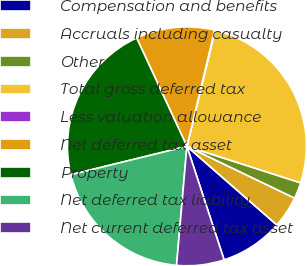Convert chart. <chart><loc_0><loc_0><loc_500><loc_500><pie_chart><fcel>Compensation and benefits<fcel>Accruals including casualty<fcel>Other<fcel>Total gross deferred tax<fcel>Less valuation allowance<fcel>Net deferred tax asset<fcel>Property<fcel>Net deferred tax liability<fcel>Net current deferred tax asset<nl><fcel>8.53%<fcel>4.3%<fcel>2.19%<fcel>26.14%<fcel>0.08%<fcel>10.64%<fcel>21.91%<fcel>19.8%<fcel>6.42%<nl></chart> 